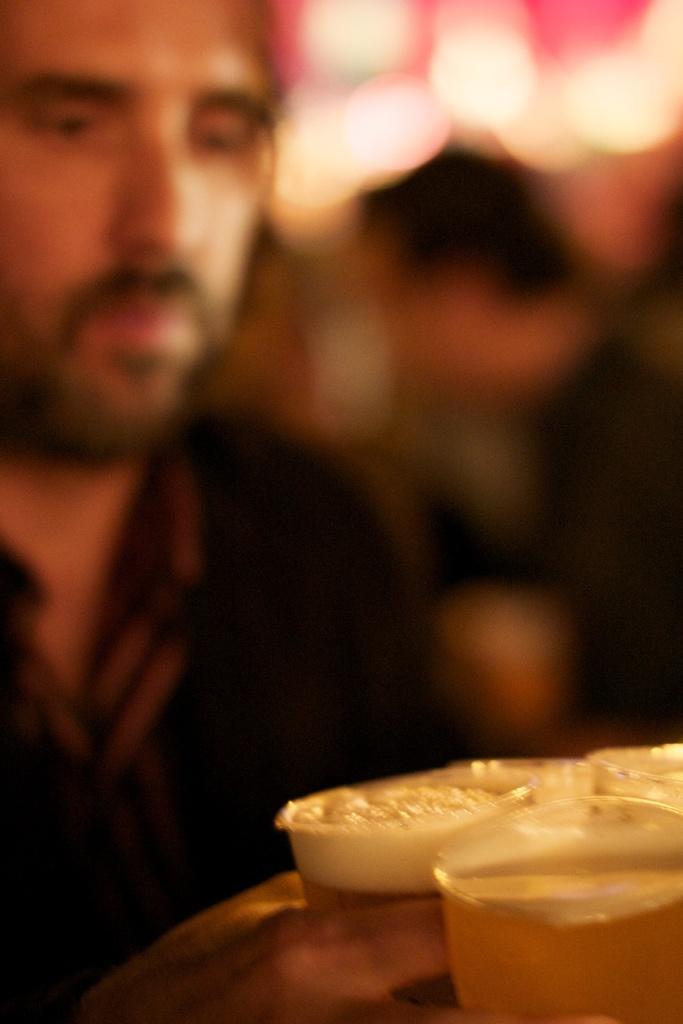In one or two sentences, can you explain what this image depicts? In the image a person is holding some glasses filled with drink and the background of the person is blur. 